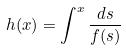Convert formula to latex. <formula><loc_0><loc_0><loc_500><loc_500>h ( x ) = \int ^ { x } \frac { d s } { f ( s ) }</formula> 